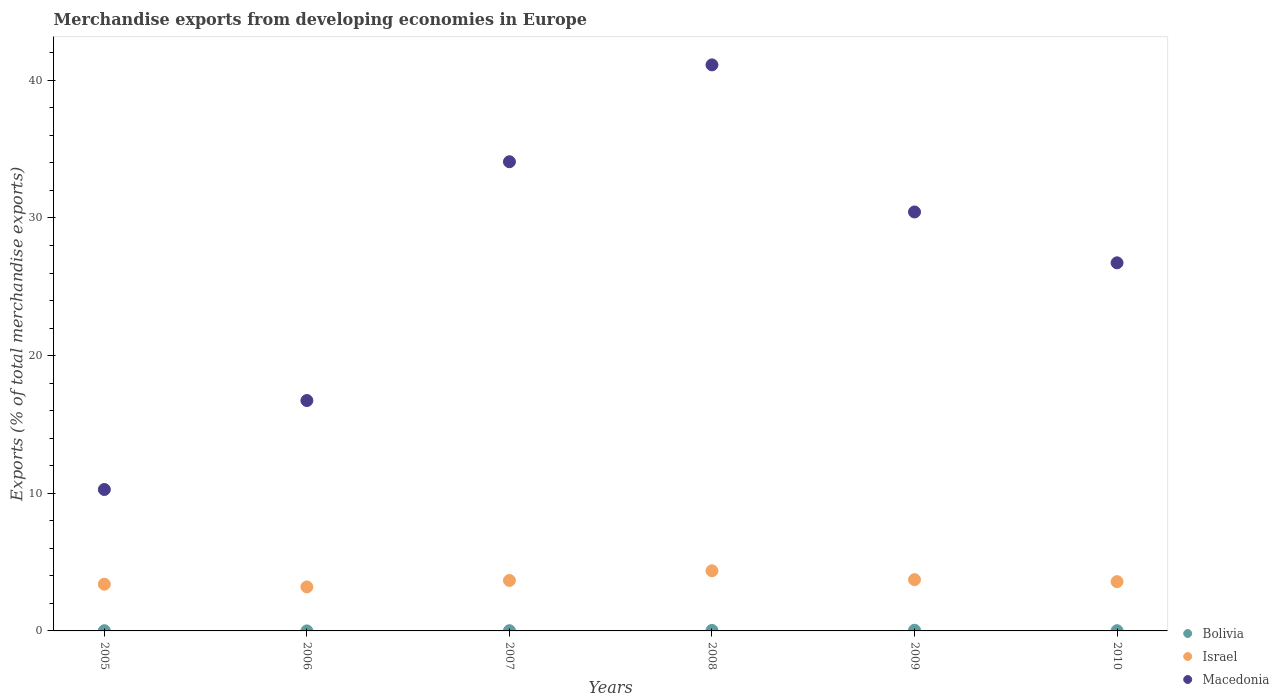Is the number of dotlines equal to the number of legend labels?
Your answer should be compact. Yes. What is the percentage of total merchandise exports in Bolivia in 2010?
Keep it short and to the point. 0.02. Across all years, what is the maximum percentage of total merchandise exports in Bolivia?
Your response must be concise. 0.05. Across all years, what is the minimum percentage of total merchandise exports in Bolivia?
Your answer should be compact. 0. What is the total percentage of total merchandise exports in Bolivia in the graph?
Your answer should be very brief. 0.13. What is the difference between the percentage of total merchandise exports in Macedonia in 2008 and that in 2009?
Offer a terse response. 10.68. What is the difference between the percentage of total merchandise exports in Israel in 2006 and the percentage of total merchandise exports in Bolivia in 2008?
Offer a very short reply. 3.16. What is the average percentage of total merchandise exports in Bolivia per year?
Ensure brevity in your answer.  0.02. In the year 2010, what is the difference between the percentage of total merchandise exports in Macedonia and percentage of total merchandise exports in Bolivia?
Make the answer very short. 26.72. What is the ratio of the percentage of total merchandise exports in Bolivia in 2005 to that in 2006?
Keep it short and to the point. 10.28. Is the percentage of total merchandise exports in Bolivia in 2005 less than that in 2006?
Your answer should be very brief. No. Is the difference between the percentage of total merchandise exports in Macedonia in 2005 and 2010 greater than the difference between the percentage of total merchandise exports in Bolivia in 2005 and 2010?
Provide a short and direct response. No. What is the difference between the highest and the second highest percentage of total merchandise exports in Israel?
Give a very brief answer. 0.64. What is the difference between the highest and the lowest percentage of total merchandise exports in Israel?
Offer a terse response. 1.17. In how many years, is the percentage of total merchandise exports in Israel greater than the average percentage of total merchandise exports in Israel taken over all years?
Offer a very short reply. 3. Is the sum of the percentage of total merchandise exports in Israel in 2005 and 2008 greater than the maximum percentage of total merchandise exports in Bolivia across all years?
Provide a succinct answer. Yes. Does the percentage of total merchandise exports in Bolivia monotonically increase over the years?
Keep it short and to the point. No. Is the percentage of total merchandise exports in Bolivia strictly greater than the percentage of total merchandise exports in Macedonia over the years?
Provide a succinct answer. No. How many dotlines are there?
Make the answer very short. 3. How many years are there in the graph?
Your answer should be very brief. 6. What is the difference between two consecutive major ticks on the Y-axis?
Provide a succinct answer. 10. How are the legend labels stacked?
Provide a succinct answer. Vertical. What is the title of the graph?
Make the answer very short. Merchandise exports from developing economies in Europe. What is the label or title of the X-axis?
Keep it short and to the point. Years. What is the label or title of the Y-axis?
Provide a succinct answer. Exports (% of total merchandise exports). What is the Exports (% of total merchandise exports) in Bolivia in 2005?
Your answer should be compact. 0.02. What is the Exports (% of total merchandise exports) in Israel in 2005?
Offer a terse response. 3.39. What is the Exports (% of total merchandise exports) in Macedonia in 2005?
Your response must be concise. 10.27. What is the Exports (% of total merchandise exports) of Bolivia in 2006?
Give a very brief answer. 0. What is the Exports (% of total merchandise exports) in Israel in 2006?
Provide a succinct answer. 3.2. What is the Exports (% of total merchandise exports) of Macedonia in 2006?
Offer a very short reply. 16.74. What is the Exports (% of total merchandise exports) of Bolivia in 2007?
Offer a very short reply. 0.02. What is the Exports (% of total merchandise exports) of Israel in 2007?
Offer a terse response. 3.66. What is the Exports (% of total merchandise exports) of Macedonia in 2007?
Your answer should be compact. 34.08. What is the Exports (% of total merchandise exports) of Bolivia in 2008?
Offer a very short reply. 0.04. What is the Exports (% of total merchandise exports) in Israel in 2008?
Provide a succinct answer. 4.37. What is the Exports (% of total merchandise exports) of Macedonia in 2008?
Provide a short and direct response. 41.12. What is the Exports (% of total merchandise exports) in Bolivia in 2009?
Provide a short and direct response. 0.05. What is the Exports (% of total merchandise exports) in Israel in 2009?
Your answer should be compact. 3.72. What is the Exports (% of total merchandise exports) of Macedonia in 2009?
Provide a succinct answer. 30.43. What is the Exports (% of total merchandise exports) in Bolivia in 2010?
Make the answer very short. 0.02. What is the Exports (% of total merchandise exports) of Israel in 2010?
Keep it short and to the point. 3.58. What is the Exports (% of total merchandise exports) in Macedonia in 2010?
Your answer should be very brief. 26.74. Across all years, what is the maximum Exports (% of total merchandise exports) of Bolivia?
Make the answer very short. 0.05. Across all years, what is the maximum Exports (% of total merchandise exports) in Israel?
Your response must be concise. 4.37. Across all years, what is the maximum Exports (% of total merchandise exports) in Macedonia?
Provide a succinct answer. 41.12. Across all years, what is the minimum Exports (% of total merchandise exports) of Bolivia?
Your answer should be compact. 0. Across all years, what is the minimum Exports (% of total merchandise exports) of Israel?
Offer a terse response. 3.2. Across all years, what is the minimum Exports (% of total merchandise exports) of Macedonia?
Provide a succinct answer. 10.27. What is the total Exports (% of total merchandise exports) of Bolivia in the graph?
Your answer should be very brief. 0.13. What is the total Exports (% of total merchandise exports) in Israel in the graph?
Make the answer very short. 21.93. What is the total Exports (% of total merchandise exports) of Macedonia in the graph?
Make the answer very short. 159.39. What is the difference between the Exports (% of total merchandise exports) in Bolivia in 2005 and that in 2006?
Your response must be concise. 0.01. What is the difference between the Exports (% of total merchandise exports) of Israel in 2005 and that in 2006?
Provide a short and direct response. 0.2. What is the difference between the Exports (% of total merchandise exports) of Macedonia in 2005 and that in 2006?
Provide a succinct answer. -6.46. What is the difference between the Exports (% of total merchandise exports) of Bolivia in 2005 and that in 2007?
Keep it short and to the point. -0. What is the difference between the Exports (% of total merchandise exports) of Israel in 2005 and that in 2007?
Provide a succinct answer. -0.27. What is the difference between the Exports (% of total merchandise exports) of Macedonia in 2005 and that in 2007?
Give a very brief answer. -23.81. What is the difference between the Exports (% of total merchandise exports) of Bolivia in 2005 and that in 2008?
Offer a terse response. -0.02. What is the difference between the Exports (% of total merchandise exports) in Israel in 2005 and that in 2008?
Offer a very short reply. -0.98. What is the difference between the Exports (% of total merchandise exports) of Macedonia in 2005 and that in 2008?
Keep it short and to the point. -30.85. What is the difference between the Exports (% of total merchandise exports) in Bolivia in 2005 and that in 2009?
Your answer should be very brief. -0.03. What is the difference between the Exports (% of total merchandise exports) of Israel in 2005 and that in 2009?
Make the answer very short. -0.33. What is the difference between the Exports (% of total merchandise exports) of Macedonia in 2005 and that in 2009?
Make the answer very short. -20.16. What is the difference between the Exports (% of total merchandise exports) of Bolivia in 2005 and that in 2010?
Give a very brief answer. 0. What is the difference between the Exports (% of total merchandise exports) of Israel in 2005 and that in 2010?
Your answer should be compact. -0.19. What is the difference between the Exports (% of total merchandise exports) in Macedonia in 2005 and that in 2010?
Your answer should be compact. -16.47. What is the difference between the Exports (% of total merchandise exports) of Bolivia in 2006 and that in 2007?
Provide a short and direct response. -0.01. What is the difference between the Exports (% of total merchandise exports) of Israel in 2006 and that in 2007?
Your answer should be very brief. -0.47. What is the difference between the Exports (% of total merchandise exports) of Macedonia in 2006 and that in 2007?
Your response must be concise. -17.35. What is the difference between the Exports (% of total merchandise exports) in Bolivia in 2006 and that in 2008?
Keep it short and to the point. -0.04. What is the difference between the Exports (% of total merchandise exports) of Israel in 2006 and that in 2008?
Provide a succinct answer. -1.17. What is the difference between the Exports (% of total merchandise exports) in Macedonia in 2006 and that in 2008?
Provide a succinct answer. -24.38. What is the difference between the Exports (% of total merchandise exports) in Bolivia in 2006 and that in 2009?
Your response must be concise. -0.05. What is the difference between the Exports (% of total merchandise exports) in Israel in 2006 and that in 2009?
Your response must be concise. -0.53. What is the difference between the Exports (% of total merchandise exports) in Macedonia in 2006 and that in 2009?
Offer a very short reply. -13.7. What is the difference between the Exports (% of total merchandise exports) of Bolivia in 2006 and that in 2010?
Offer a very short reply. -0.01. What is the difference between the Exports (% of total merchandise exports) of Israel in 2006 and that in 2010?
Make the answer very short. -0.38. What is the difference between the Exports (% of total merchandise exports) of Macedonia in 2006 and that in 2010?
Your answer should be very brief. -10. What is the difference between the Exports (% of total merchandise exports) of Bolivia in 2007 and that in 2008?
Your answer should be very brief. -0.02. What is the difference between the Exports (% of total merchandise exports) of Israel in 2007 and that in 2008?
Your answer should be compact. -0.7. What is the difference between the Exports (% of total merchandise exports) of Macedonia in 2007 and that in 2008?
Offer a very short reply. -7.04. What is the difference between the Exports (% of total merchandise exports) of Bolivia in 2007 and that in 2009?
Ensure brevity in your answer.  -0.03. What is the difference between the Exports (% of total merchandise exports) in Israel in 2007 and that in 2009?
Your answer should be compact. -0.06. What is the difference between the Exports (% of total merchandise exports) of Macedonia in 2007 and that in 2009?
Offer a very short reply. 3.65. What is the difference between the Exports (% of total merchandise exports) of Israel in 2007 and that in 2010?
Provide a succinct answer. 0.08. What is the difference between the Exports (% of total merchandise exports) in Macedonia in 2007 and that in 2010?
Your answer should be compact. 7.34. What is the difference between the Exports (% of total merchandise exports) in Bolivia in 2008 and that in 2009?
Provide a succinct answer. -0.01. What is the difference between the Exports (% of total merchandise exports) in Israel in 2008 and that in 2009?
Provide a succinct answer. 0.64. What is the difference between the Exports (% of total merchandise exports) of Macedonia in 2008 and that in 2009?
Ensure brevity in your answer.  10.68. What is the difference between the Exports (% of total merchandise exports) of Bolivia in 2008 and that in 2010?
Make the answer very short. 0.02. What is the difference between the Exports (% of total merchandise exports) of Israel in 2008 and that in 2010?
Your response must be concise. 0.79. What is the difference between the Exports (% of total merchandise exports) in Macedonia in 2008 and that in 2010?
Offer a very short reply. 14.38. What is the difference between the Exports (% of total merchandise exports) of Bolivia in 2009 and that in 2010?
Provide a succinct answer. 0.03. What is the difference between the Exports (% of total merchandise exports) in Israel in 2009 and that in 2010?
Provide a short and direct response. 0.15. What is the difference between the Exports (% of total merchandise exports) in Macedonia in 2009 and that in 2010?
Your answer should be compact. 3.7. What is the difference between the Exports (% of total merchandise exports) in Bolivia in 2005 and the Exports (% of total merchandise exports) in Israel in 2006?
Ensure brevity in your answer.  -3.18. What is the difference between the Exports (% of total merchandise exports) in Bolivia in 2005 and the Exports (% of total merchandise exports) in Macedonia in 2006?
Provide a succinct answer. -16.72. What is the difference between the Exports (% of total merchandise exports) in Israel in 2005 and the Exports (% of total merchandise exports) in Macedonia in 2006?
Make the answer very short. -13.34. What is the difference between the Exports (% of total merchandise exports) of Bolivia in 2005 and the Exports (% of total merchandise exports) of Israel in 2007?
Ensure brevity in your answer.  -3.65. What is the difference between the Exports (% of total merchandise exports) of Bolivia in 2005 and the Exports (% of total merchandise exports) of Macedonia in 2007?
Make the answer very short. -34.07. What is the difference between the Exports (% of total merchandise exports) of Israel in 2005 and the Exports (% of total merchandise exports) of Macedonia in 2007?
Ensure brevity in your answer.  -30.69. What is the difference between the Exports (% of total merchandise exports) in Bolivia in 2005 and the Exports (% of total merchandise exports) in Israel in 2008?
Your response must be concise. -4.35. What is the difference between the Exports (% of total merchandise exports) in Bolivia in 2005 and the Exports (% of total merchandise exports) in Macedonia in 2008?
Your response must be concise. -41.1. What is the difference between the Exports (% of total merchandise exports) of Israel in 2005 and the Exports (% of total merchandise exports) of Macedonia in 2008?
Your answer should be compact. -37.73. What is the difference between the Exports (% of total merchandise exports) in Bolivia in 2005 and the Exports (% of total merchandise exports) in Israel in 2009?
Ensure brevity in your answer.  -3.71. What is the difference between the Exports (% of total merchandise exports) in Bolivia in 2005 and the Exports (% of total merchandise exports) in Macedonia in 2009?
Offer a terse response. -30.42. What is the difference between the Exports (% of total merchandise exports) in Israel in 2005 and the Exports (% of total merchandise exports) in Macedonia in 2009?
Your answer should be very brief. -27.04. What is the difference between the Exports (% of total merchandise exports) in Bolivia in 2005 and the Exports (% of total merchandise exports) in Israel in 2010?
Your answer should be compact. -3.56. What is the difference between the Exports (% of total merchandise exports) in Bolivia in 2005 and the Exports (% of total merchandise exports) in Macedonia in 2010?
Your answer should be very brief. -26.72. What is the difference between the Exports (% of total merchandise exports) of Israel in 2005 and the Exports (% of total merchandise exports) of Macedonia in 2010?
Your response must be concise. -23.35. What is the difference between the Exports (% of total merchandise exports) of Bolivia in 2006 and the Exports (% of total merchandise exports) of Israel in 2007?
Keep it short and to the point. -3.66. What is the difference between the Exports (% of total merchandise exports) of Bolivia in 2006 and the Exports (% of total merchandise exports) of Macedonia in 2007?
Your response must be concise. -34.08. What is the difference between the Exports (% of total merchandise exports) of Israel in 2006 and the Exports (% of total merchandise exports) of Macedonia in 2007?
Provide a short and direct response. -30.89. What is the difference between the Exports (% of total merchandise exports) of Bolivia in 2006 and the Exports (% of total merchandise exports) of Israel in 2008?
Make the answer very short. -4.37. What is the difference between the Exports (% of total merchandise exports) in Bolivia in 2006 and the Exports (% of total merchandise exports) in Macedonia in 2008?
Ensure brevity in your answer.  -41.12. What is the difference between the Exports (% of total merchandise exports) of Israel in 2006 and the Exports (% of total merchandise exports) of Macedonia in 2008?
Provide a short and direct response. -37.92. What is the difference between the Exports (% of total merchandise exports) of Bolivia in 2006 and the Exports (% of total merchandise exports) of Israel in 2009?
Your answer should be compact. -3.72. What is the difference between the Exports (% of total merchandise exports) of Bolivia in 2006 and the Exports (% of total merchandise exports) of Macedonia in 2009?
Keep it short and to the point. -30.43. What is the difference between the Exports (% of total merchandise exports) of Israel in 2006 and the Exports (% of total merchandise exports) of Macedonia in 2009?
Ensure brevity in your answer.  -27.24. What is the difference between the Exports (% of total merchandise exports) of Bolivia in 2006 and the Exports (% of total merchandise exports) of Israel in 2010?
Your answer should be compact. -3.58. What is the difference between the Exports (% of total merchandise exports) in Bolivia in 2006 and the Exports (% of total merchandise exports) in Macedonia in 2010?
Provide a succinct answer. -26.74. What is the difference between the Exports (% of total merchandise exports) of Israel in 2006 and the Exports (% of total merchandise exports) of Macedonia in 2010?
Make the answer very short. -23.54. What is the difference between the Exports (% of total merchandise exports) in Bolivia in 2007 and the Exports (% of total merchandise exports) in Israel in 2008?
Keep it short and to the point. -4.35. What is the difference between the Exports (% of total merchandise exports) of Bolivia in 2007 and the Exports (% of total merchandise exports) of Macedonia in 2008?
Your response must be concise. -41.1. What is the difference between the Exports (% of total merchandise exports) of Israel in 2007 and the Exports (% of total merchandise exports) of Macedonia in 2008?
Keep it short and to the point. -37.46. What is the difference between the Exports (% of total merchandise exports) of Bolivia in 2007 and the Exports (% of total merchandise exports) of Israel in 2009?
Provide a short and direct response. -3.71. What is the difference between the Exports (% of total merchandise exports) of Bolivia in 2007 and the Exports (% of total merchandise exports) of Macedonia in 2009?
Give a very brief answer. -30.42. What is the difference between the Exports (% of total merchandise exports) in Israel in 2007 and the Exports (% of total merchandise exports) in Macedonia in 2009?
Make the answer very short. -26.77. What is the difference between the Exports (% of total merchandise exports) of Bolivia in 2007 and the Exports (% of total merchandise exports) of Israel in 2010?
Make the answer very short. -3.56. What is the difference between the Exports (% of total merchandise exports) in Bolivia in 2007 and the Exports (% of total merchandise exports) in Macedonia in 2010?
Your answer should be compact. -26.72. What is the difference between the Exports (% of total merchandise exports) in Israel in 2007 and the Exports (% of total merchandise exports) in Macedonia in 2010?
Offer a very short reply. -23.08. What is the difference between the Exports (% of total merchandise exports) in Bolivia in 2008 and the Exports (% of total merchandise exports) in Israel in 2009?
Your answer should be very brief. -3.69. What is the difference between the Exports (% of total merchandise exports) in Bolivia in 2008 and the Exports (% of total merchandise exports) in Macedonia in 2009?
Provide a succinct answer. -30.4. What is the difference between the Exports (% of total merchandise exports) of Israel in 2008 and the Exports (% of total merchandise exports) of Macedonia in 2009?
Your answer should be compact. -26.07. What is the difference between the Exports (% of total merchandise exports) of Bolivia in 2008 and the Exports (% of total merchandise exports) of Israel in 2010?
Your answer should be compact. -3.54. What is the difference between the Exports (% of total merchandise exports) of Bolivia in 2008 and the Exports (% of total merchandise exports) of Macedonia in 2010?
Offer a terse response. -26.7. What is the difference between the Exports (% of total merchandise exports) in Israel in 2008 and the Exports (% of total merchandise exports) in Macedonia in 2010?
Make the answer very short. -22.37. What is the difference between the Exports (% of total merchandise exports) of Bolivia in 2009 and the Exports (% of total merchandise exports) of Israel in 2010?
Offer a terse response. -3.53. What is the difference between the Exports (% of total merchandise exports) in Bolivia in 2009 and the Exports (% of total merchandise exports) in Macedonia in 2010?
Your response must be concise. -26.69. What is the difference between the Exports (% of total merchandise exports) in Israel in 2009 and the Exports (% of total merchandise exports) in Macedonia in 2010?
Provide a short and direct response. -23.01. What is the average Exports (% of total merchandise exports) of Bolivia per year?
Offer a very short reply. 0.02. What is the average Exports (% of total merchandise exports) in Israel per year?
Provide a short and direct response. 3.65. What is the average Exports (% of total merchandise exports) in Macedonia per year?
Make the answer very short. 26.56. In the year 2005, what is the difference between the Exports (% of total merchandise exports) in Bolivia and Exports (% of total merchandise exports) in Israel?
Offer a terse response. -3.38. In the year 2005, what is the difference between the Exports (% of total merchandise exports) in Bolivia and Exports (% of total merchandise exports) in Macedonia?
Provide a short and direct response. -10.26. In the year 2005, what is the difference between the Exports (% of total merchandise exports) of Israel and Exports (% of total merchandise exports) of Macedonia?
Keep it short and to the point. -6.88. In the year 2006, what is the difference between the Exports (% of total merchandise exports) in Bolivia and Exports (% of total merchandise exports) in Israel?
Make the answer very short. -3.2. In the year 2006, what is the difference between the Exports (% of total merchandise exports) in Bolivia and Exports (% of total merchandise exports) in Macedonia?
Provide a succinct answer. -16.73. In the year 2006, what is the difference between the Exports (% of total merchandise exports) of Israel and Exports (% of total merchandise exports) of Macedonia?
Your answer should be compact. -13.54. In the year 2007, what is the difference between the Exports (% of total merchandise exports) in Bolivia and Exports (% of total merchandise exports) in Israel?
Offer a terse response. -3.65. In the year 2007, what is the difference between the Exports (% of total merchandise exports) of Bolivia and Exports (% of total merchandise exports) of Macedonia?
Your response must be concise. -34.07. In the year 2007, what is the difference between the Exports (% of total merchandise exports) of Israel and Exports (% of total merchandise exports) of Macedonia?
Your answer should be compact. -30.42. In the year 2008, what is the difference between the Exports (% of total merchandise exports) of Bolivia and Exports (% of total merchandise exports) of Israel?
Make the answer very short. -4.33. In the year 2008, what is the difference between the Exports (% of total merchandise exports) in Bolivia and Exports (% of total merchandise exports) in Macedonia?
Your answer should be compact. -41.08. In the year 2008, what is the difference between the Exports (% of total merchandise exports) of Israel and Exports (% of total merchandise exports) of Macedonia?
Keep it short and to the point. -36.75. In the year 2009, what is the difference between the Exports (% of total merchandise exports) in Bolivia and Exports (% of total merchandise exports) in Israel?
Your answer should be compact. -3.68. In the year 2009, what is the difference between the Exports (% of total merchandise exports) of Bolivia and Exports (% of total merchandise exports) of Macedonia?
Your response must be concise. -30.39. In the year 2009, what is the difference between the Exports (% of total merchandise exports) in Israel and Exports (% of total merchandise exports) in Macedonia?
Your response must be concise. -26.71. In the year 2010, what is the difference between the Exports (% of total merchandise exports) in Bolivia and Exports (% of total merchandise exports) in Israel?
Your answer should be compact. -3.56. In the year 2010, what is the difference between the Exports (% of total merchandise exports) in Bolivia and Exports (% of total merchandise exports) in Macedonia?
Offer a terse response. -26.72. In the year 2010, what is the difference between the Exports (% of total merchandise exports) of Israel and Exports (% of total merchandise exports) of Macedonia?
Ensure brevity in your answer.  -23.16. What is the ratio of the Exports (% of total merchandise exports) in Bolivia in 2005 to that in 2006?
Your answer should be very brief. 10.28. What is the ratio of the Exports (% of total merchandise exports) in Israel in 2005 to that in 2006?
Offer a terse response. 1.06. What is the ratio of the Exports (% of total merchandise exports) in Macedonia in 2005 to that in 2006?
Offer a terse response. 0.61. What is the ratio of the Exports (% of total merchandise exports) in Bolivia in 2005 to that in 2007?
Your answer should be very brief. 0.98. What is the ratio of the Exports (% of total merchandise exports) of Israel in 2005 to that in 2007?
Your response must be concise. 0.93. What is the ratio of the Exports (% of total merchandise exports) of Macedonia in 2005 to that in 2007?
Provide a short and direct response. 0.3. What is the ratio of the Exports (% of total merchandise exports) of Bolivia in 2005 to that in 2008?
Keep it short and to the point. 0.43. What is the ratio of the Exports (% of total merchandise exports) in Israel in 2005 to that in 2008?
Make the answer very short. 0.78. What is the ratio of the Exports (% of total merchandise exports) in Macedonia in 2005 to that in 2008?
Ensure brevity in your answer.  0.25. What is the ratio of the Exports (% of total merchandise exports) of Bolivia in 2005 to that in 2009?
Give a very brief answer. 0.33. What is the ratio of the Exports (% of total merchandise exports) in Israel in 2005 to that in 2009?
Provide a succinct answer. 0.91. What is the ratio of the Exports (% of total merchandise exports) in Macedonia in 2005 to that in 2009?
Ensure brevity in your answer.  0.34. What is the ratio of the Exports (% of total merchandise exports) in Bolivia in 2005 to that in 2010?
Offer a very short reply. 1.05. What is the ratio of the Exports (% of total merchandise exports) of Israel in 2005 to that in 2010?
Offer a terse response. 0.95. What is the ratio of the Exports (% of total merchandise exports) in Macedonia in 2005 to that in 2010?
Give a very brief answer. 0.38. What is the ratio of the Exports (% of total merchandise exports) in Bolivia in 2006 to that in 2007?
Provide a succinct answer. 0.1. What is the ratio of the Exports (% of total merchandise exports) in Israel in 2006 to that in 2007?
Keep it short and to the point. 0.87. What is the ratio of the Exports (% of total merchandise exports) of Macedonia in 2006 to that in 2007?
Keep it short and to the point. 0.49. What is the ratio of the Exports (% of total merchandise exports) in Bolivia in 2006 to that in 2008?
Give a very brief answer. 0.04. What is the ratio of the Exports (% of total merchandise exports) in Israel in 2006 to that in 2008?
Keep it short and to the point. 0.73. What is the ratio of the Exports (% of total merchandise exports) in Macedonia in 2006 to that in 2008?
Keep it short and to the point. 0.41. What is the ratio of the Exports (% of total merchandise exports) of Bolivia in 2006 to that in 2009?
Make the answer very short. 0.03. What is the ratio of the Exports (% of total merchandise exports) of Israel in 2006 to that in 2009?
Offer a terse response. 0.86. What is the ratio of the Exports (% of total merchandise exports) in Macedonia in 2006 to that in 2009?
Offer a very short reply. 0.55. What is the ratio of the Exports (% of total merchandise exports) in Bolivia in 2006 to that in 2010?
Give a very brief answer. 0.1. What is the ratio of the Exports (% of total merchandise exports) in Israel in 2006 to that in 2010?
Provide a succinct answer. 0.89. What is the ratio of the Exports (% of total merchandise exports) of Macedonia in 2006 to that in 2010?
Make the answer very short. 0.63. What is the ratio of the Exports (% of total merchandise exports) in Bolivia in 2007 to that in 2008?
Give a very brief answer. 0.44. What is the ratio of the Exports (% of total merchandise exports) of Israel in 2007 to that in 2008?
Ensure brevity in your answer.  0.84. What is the ratio of the Exports (% of total merchandise exports) of Macedonia in 2007 to that in 2008?
Offer a terse response. 0.83. What is the ratio of the Exports (% of total merchandise exports) in Bolivia in 2007 to that in 2009?
Your answer should be very brief. 0.33. What is the ratio of the Exports (% of total merchandise exports) of Israel in 2007 to that in 2009?
Offer a very short reply. 0.98. What is the ratio of the Exports (% of total merchandise exports) in Macedonia in 2007 to that in 2009?
Give a very brief answer. 1.12. What is the ratio of the Exports (% of total merchandise exports) in Bolivia in 2007 to that in 2010?
Your answer should be very brief. 1.07. What is the ratio of the Exports (% of total merchandise exports) in Israel in 2007 to that in 2010?
Your response must be concise. 1.02. What is the ratio of the Exports (% of total merchandise exports) of Macedonia in 2007 to that in 2010?
Offer a very short reply. 1.27. What is the ratio of the Exports (% of total merchandise exports) in Bolivia in 2008 to that in 2009?
Make the answer very short. 0.75. What is the ratio of the Exports (% of total merchandise exports) of Israel in 2008 to that in 2009?
Make the answer very short. 1.17. What is the ratio of the Exports (% of total merchandise exports) of Macedonia in 2008 to that in 2009?
Ensure brevity in your answer.  1.35. What is the ratio of the Exports (% of total merchandise exports) of Bolivia in 2008 to that in 2010?
Make the answer very short. 2.42. What is the ratio of the Exports (% of total merchandise exports) in Israel in 2008 to that in 2010?
Make the answer very short. 1.22. What is the ratio of the Exports (% of total merchandise exports) in Macedonia in 2008 to that in 2010?
Provide a short and direct response. 1.54. What is the ratio of the Exports (% of total merchandise exports) of Bolivia in 2009 to that in 2010?
Give a very brief answer. 3.21. What is the ratio of the Exports (% of total merchandise exports) in Israel in 2009 to that in 2010?
Offer a very short reply. 1.04. What is the ratio of the Exports (% of total merchandise exports) of Macedonia in 2009 to that in 2010?
Provide a succinct answer. 1.14. What is the difference between the highest and the second highest Exports (% of total merchandise exports) of Bolivia?
Your response must be concise. 0.01. What is the difference between the highest and the second highest Exports (% of total merchandise exports) in Israel?
Offer a very short reply. 0.64. What is the difference between the highest and the second highest Exports (% of total merchandise exports) in Macedonia?
Keep it short and to the point. 7.04. What is the difference between the highest and the lowest Exports (% of total merchandise exports) in Bolivia?
Your answer should be very brief. 0.05. What is the difference between the highest and the lowest Exports (% of total merchandise exports) in Israel?
Provide a succinct answer. 1.17. What is the difference between the highest and the lowest Exports (% of total merchandise exports) in Macedonia?
Your answer should be very brief. 30.85. 